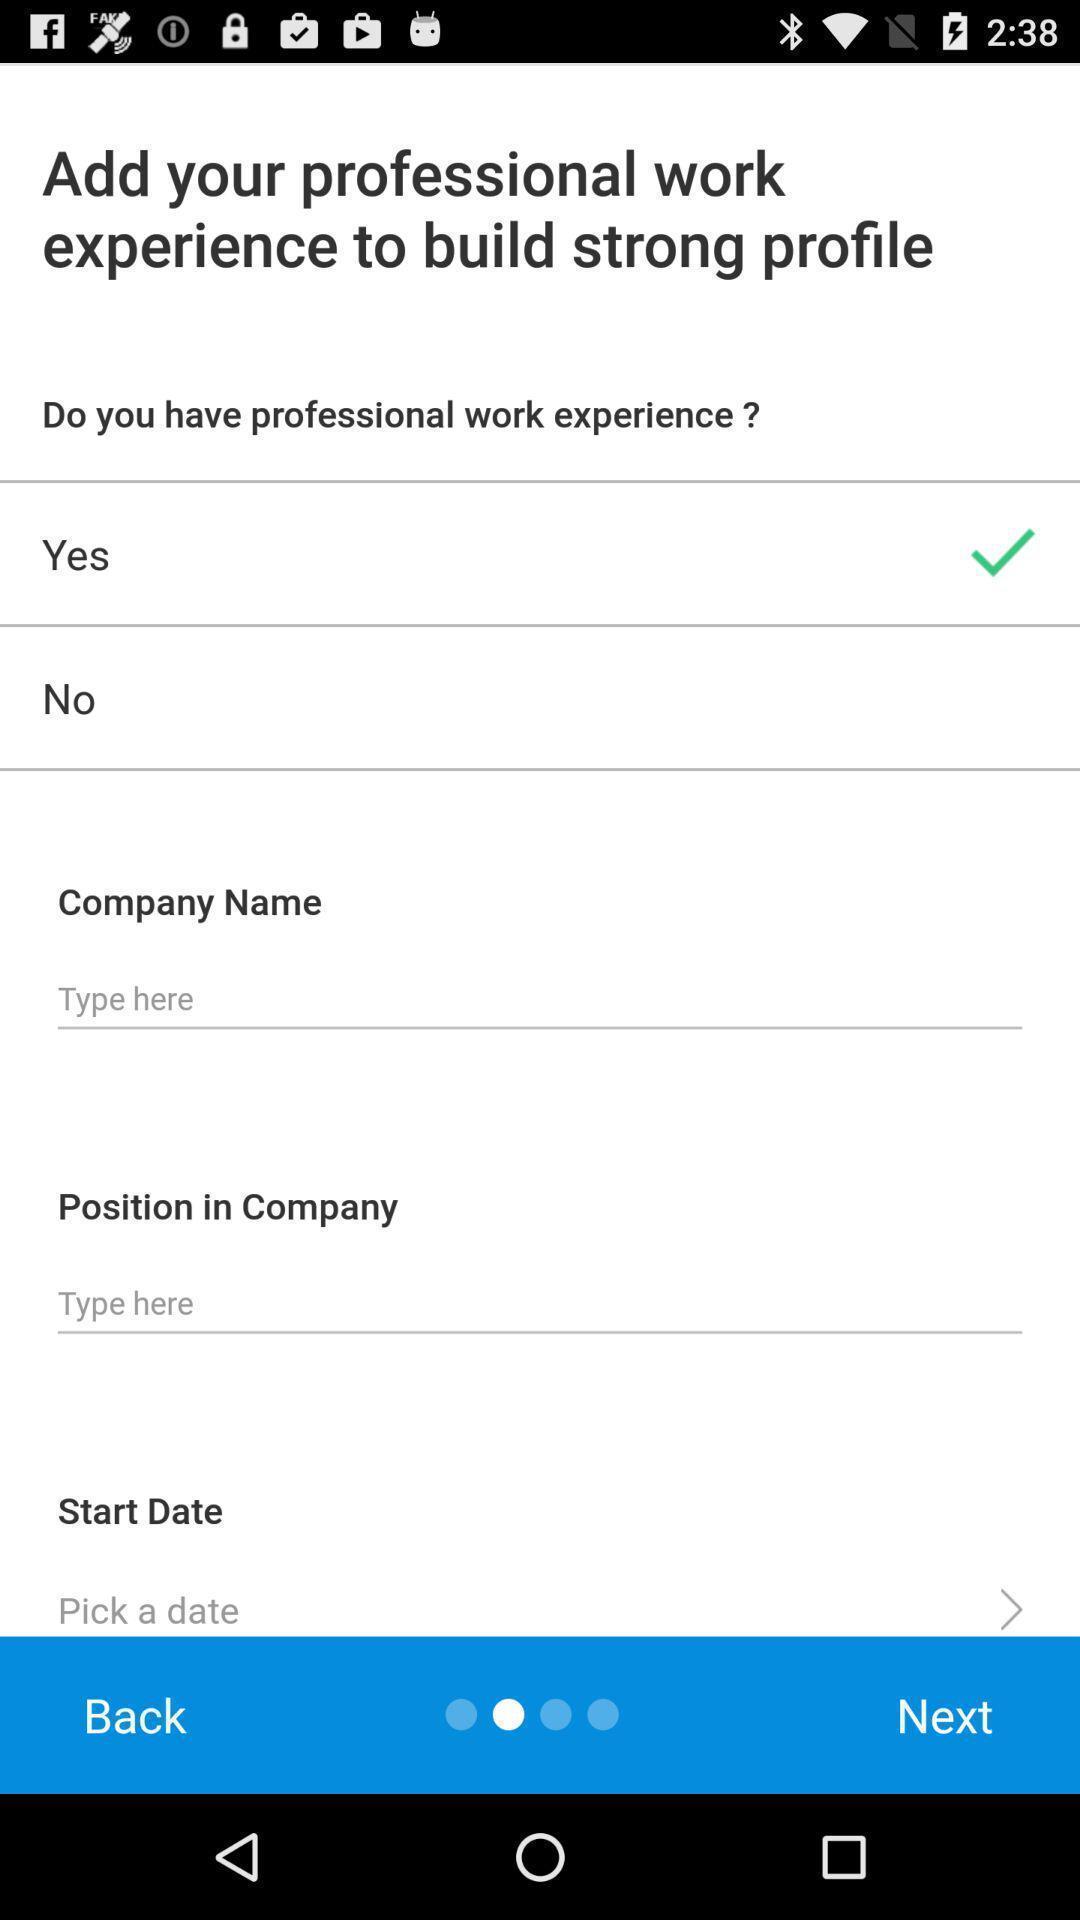Explain what's happening in this screen capture. Page to add the profile for the job search app. 